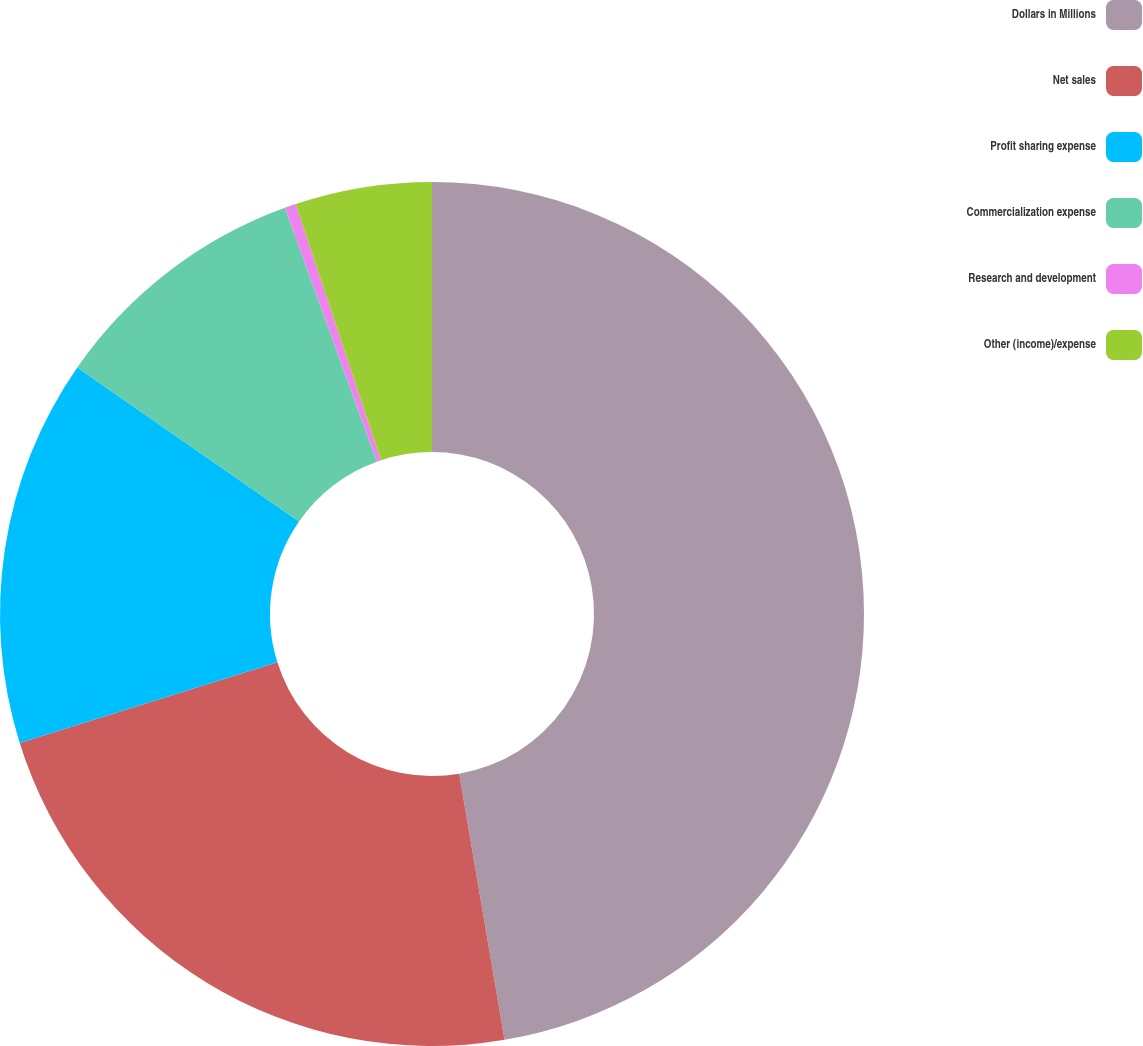Convert chart to OTSL. <chart><loc_0><loc_0><loc_500><loc_500><pie_chart><fcel>Dollars in Millions<fcel>Net sales<fcel>Profit sharing expense<fcel>Commercialization expense<fcel>Research and development<fcel>Other (income)/expense<nl><fcel>47.31%<fcel>22.86%<fcel>14.49%<fcel>9.8%<fcel>0.42%<fcel>5.11%<nl></chart> 